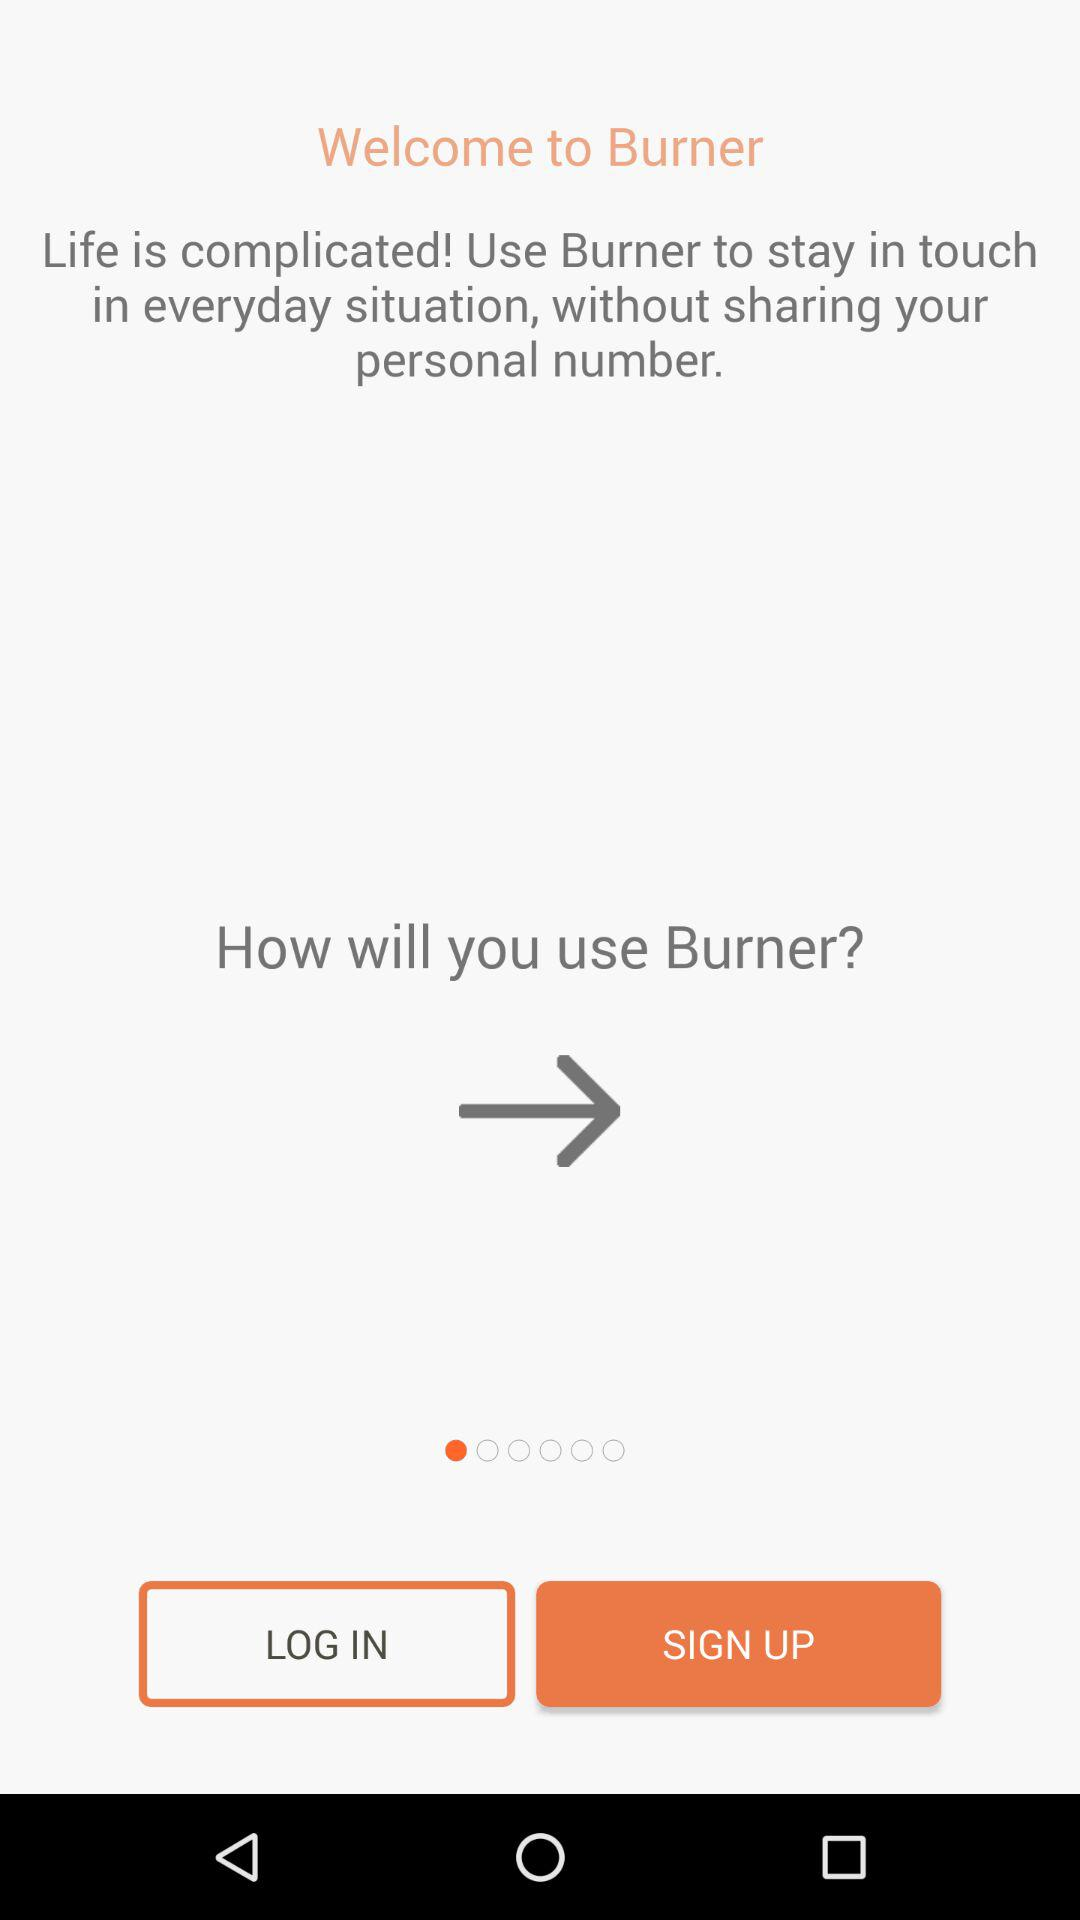How we can continue to see information?
When the provided information is insufficient, respond with <no answer>. <no answer> 